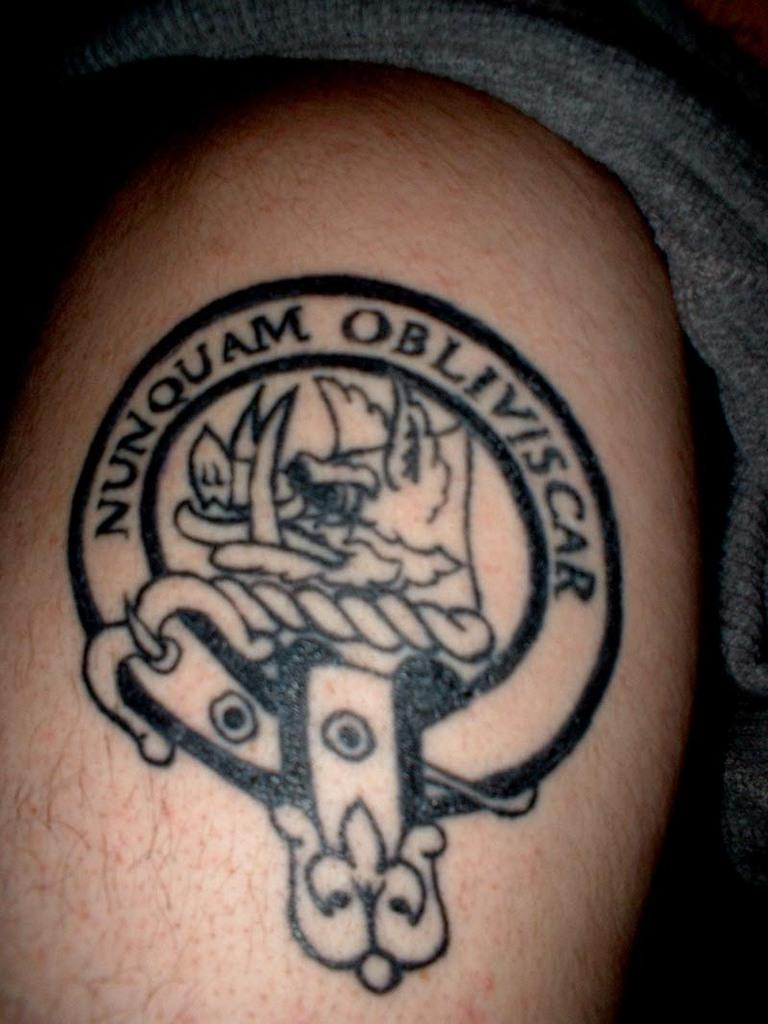What is the main subject of the image? The image contains a human body. Are there any distinguishing features on the body? Yes, there is a tattoo on the body. What else can be seen in the image besides the human body? Cloth is present in the image. What is the color of the background in the image? The background of the image is dark. What type of magic is being performed by the person in the image? There is no indication of magic or any magical activity in the image. What kind of quilt is being used to cover the person in the image? There is no quilt present in the image; only cloth is mentioned. 